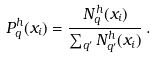Convert formula to latex. <formula><loc_0><loc_0><loc_500><loc_500>P _ { q } ^ { h } ( x _ { i } ) = \frac { N _ { q } ^ { h } ( x _ { i } ) } { \sum _ { q ^ { \prime } } N _ { q ^ { \prime } } ^ { h } ( x _ { i } ) } \, .</formula> 